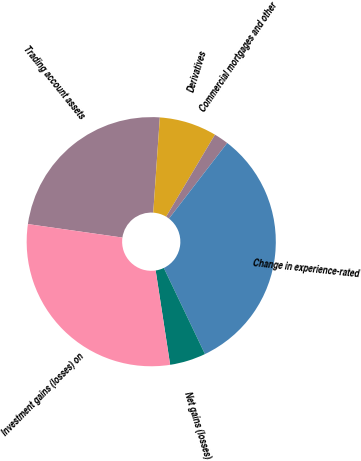Convert chart. <chart><loc_0><loc_0><loc_500><loc_500><pie_chart><fcel>Trading account assets<fcel>Derivatives<fcel>Commercial mortgages and other<fcel>Change in experience-rated<fcel>Net gains (losses)<fcel>Investment gains (losses) on<nl><fcel>23.84%<fcel>7.45%<fcel>1.89%<fcel>32.46%<fcel>4.67%<fcel>29.68%<nl></chart> 